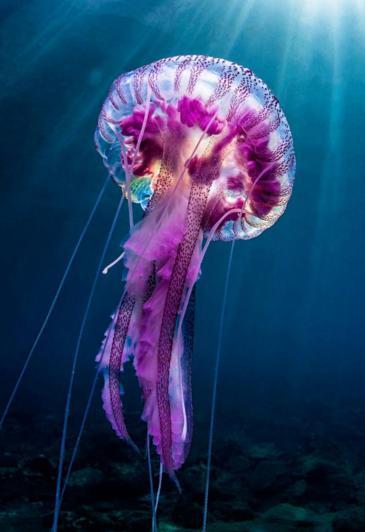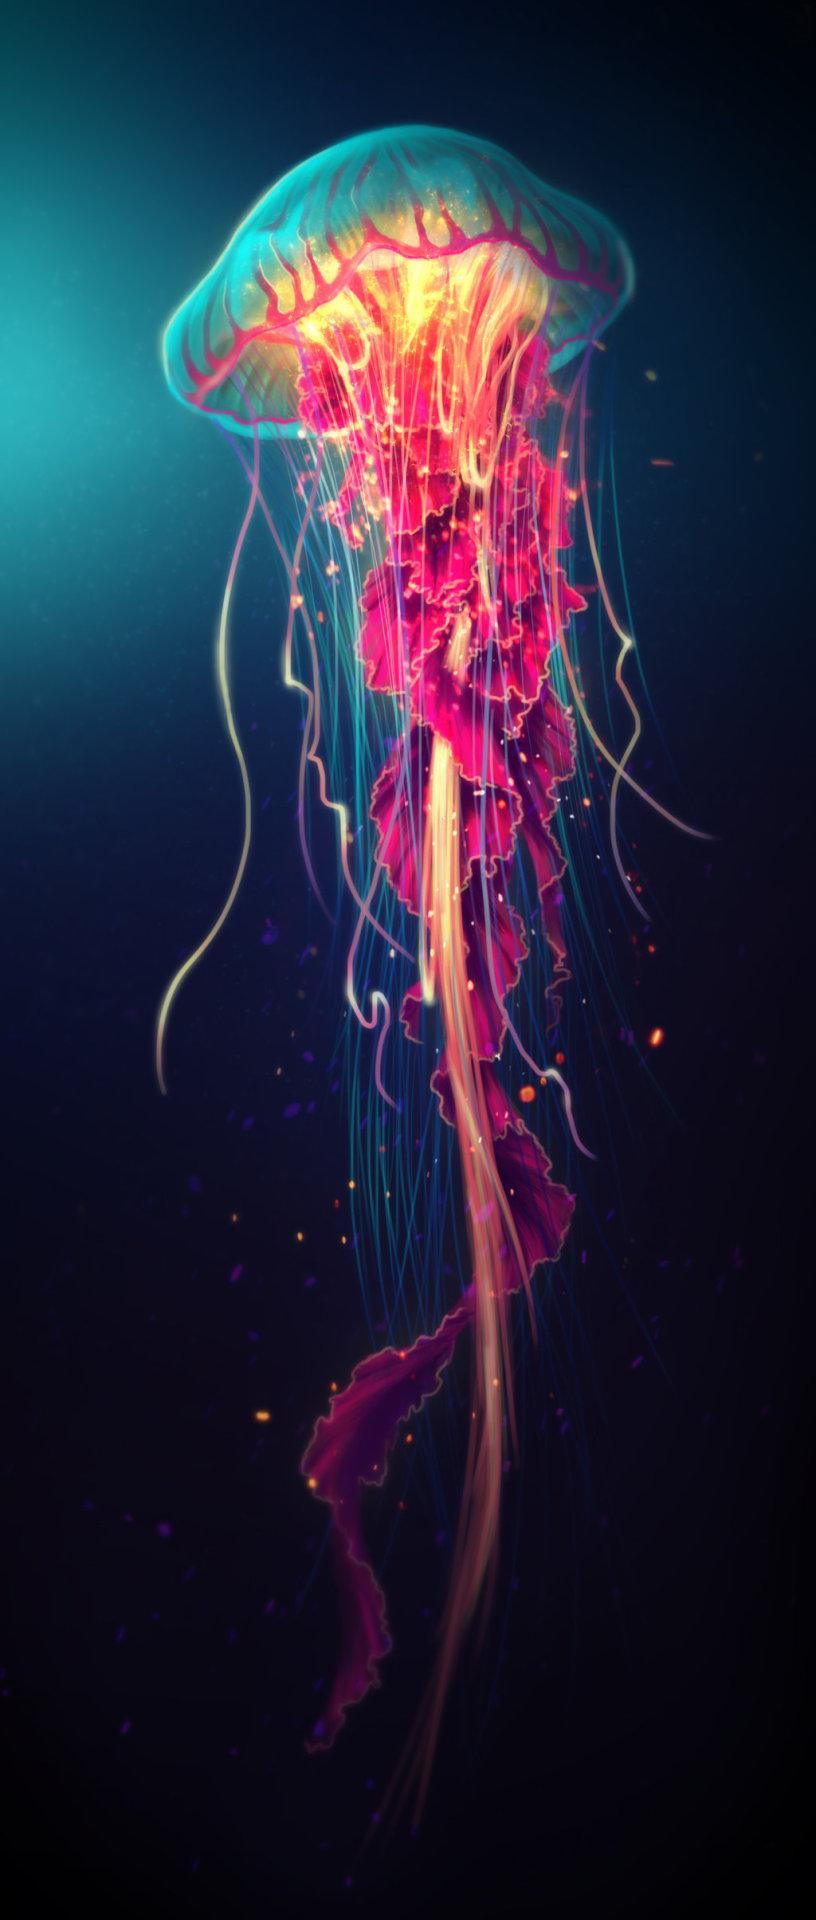The first image is the image on the left, the second image is the image on the right. Examine the images to the left and right. Is the description "Left image shows multiple disk-shaped hot-pink jellyfish on a blue background." accurate? Answer yes or no. No. The first image is the image on the left, the second image is the image on the right. Assess this claim about the two images: "There are multiple jellyfish in water in the right image.". Correct or not? Answer yes or no. No. 